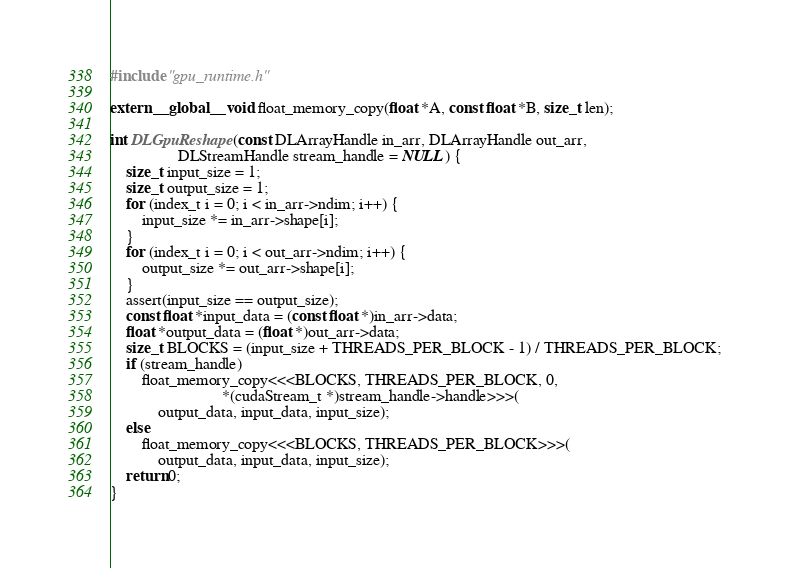Convert code to text. <code><loc_0><loc_0><loc_500><loc_500><_Cuda_>#include "gpu_runtime.h"

extern __global__ void float_memory_copy(float *A, const float *B, size_t len);

int DLGpuReshape(const DLArrayHandle in_arr, DLArrayHandle out_arr,
                 DLStreamHandle stream_handle = NULL) {
    size_t input_size = 1;
    size_t output_size = 1;
    for (index_t i = 0; i < in_arr->ndim; i++) {
        input_size *= in_arr->shape[i];
    }
    for (index_t i = 0; i < out_arr->ndim; i++) {
        output_size *= out_arr->shape[i];
    }
    assert(input_size == output_size);
    const float *input_data = (const float *)in_arr->data;
    float *output_data = (float *)out_arr->data;
    size_t BLOCKS = (input_size + THREADS_PER_BLOCK - 1) / THREADS_PER_BLOCK;
    if (stream_handle)
        float_memory_copy<<<BLOCKS, THREADS_PER_BLOCK, 0,
                            *(cudaStream_t *)stream_handle->handle>>>(
            output_data, input_data, input_size);
    else
        float_memory_copy<<<BLOCKS, THREADS_PER_BLOCK>>>(
            output_data, input_data, input_size);
    return 0;
}</code> 